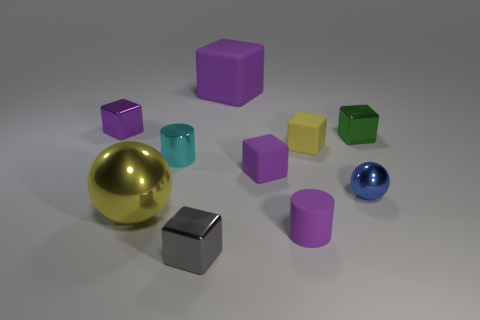Is there any other thing that has the same size as the gray metallic cube?
Your answer should be very brief. Yes. Do the big ball and the big cube have the same color?
Provide a succinct answer. No. Are there more small cyan objects than cyan balls?
Keep it short and to the point. Yes. What number of other things are the same color as the large matte object?
Make the answer very short. 3. There is a large object behind the cyan metallic cylinder; what number of tiny cyan objects are right of it?
Provide a succinct answer. 0. There is a small blue metal sphere; are there any tiny purple metal blocks in front of it?
Offer a very short reply. No. What shape is the tiny purple object that is left of the tiny metal block in front of the yellow block?
Keep it short and to the point. Cube. Are there fewer small gray blocks behind the small yellow object than big purple matte blocks behind the tiny green object?
Keep it short and to the point. Yes. What is the color of the other large thing that is the same shape as the yellow rubber object?
Keep it short and to the point. Purple. What number of tiny blocks are both left of the green cube and behind the gray metallic object?
Make the answer very short. 3. 